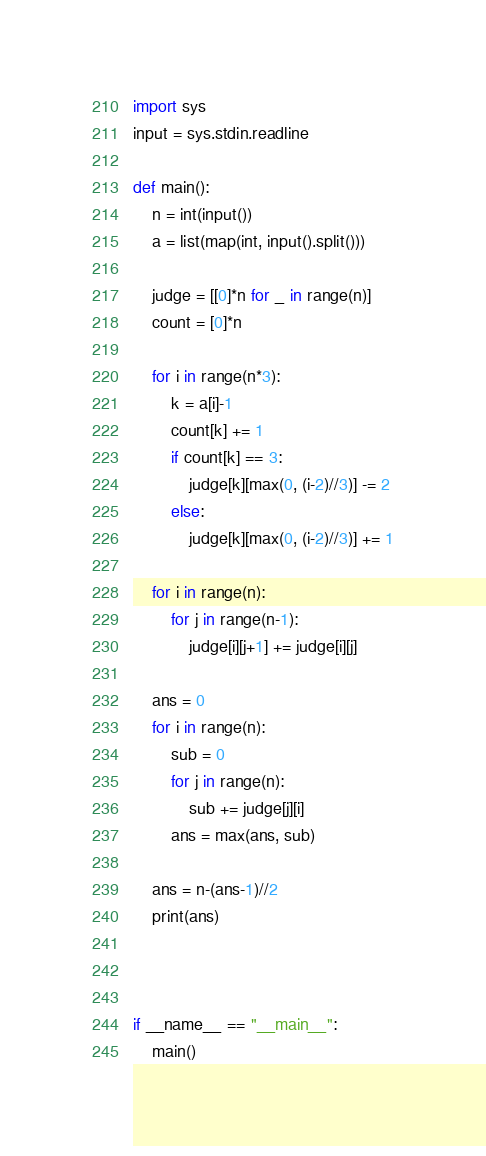Convert code to text. <code><loc_0><loc_0><loc_500><loc_500><_Python_>
import sys
input = sys.stdin.readline

def main():
    n = int(input())
    a = list(map(int, input().split()))
    
    judge = [[0]*n for _ in range(n)]
    count = [0]*n
    
    for i in range(n*3):
        k = a[i]-1
        count[k] += 1
        if count[k] == 3:
            judge[k][max(0, (i-2)//3)] -= 2
        else:
            judge[k][max(0, (i-2)//3)] += 1
    
    for i in range(n):
        for j in range(n-1):
            judge[i][j+1] += judge[i][j]
    
    ans = 0
    for i in range(n):
        sub = 0
        for j in range(n):
            sub += judge[j][i]
        ans = max(ans, sub)
    
    ans = n-(ans-1)//2
    print(ans)
            
    
    
if __name__ == "__main__":
    main()

</code> 